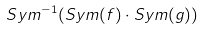Convert formula to latex. <formula><loc_0><loc_0><loc_500><loc_500>S y m ^ { - 1 } ( S y m ( f ) \cdot S y m ( g ) )</formula> 